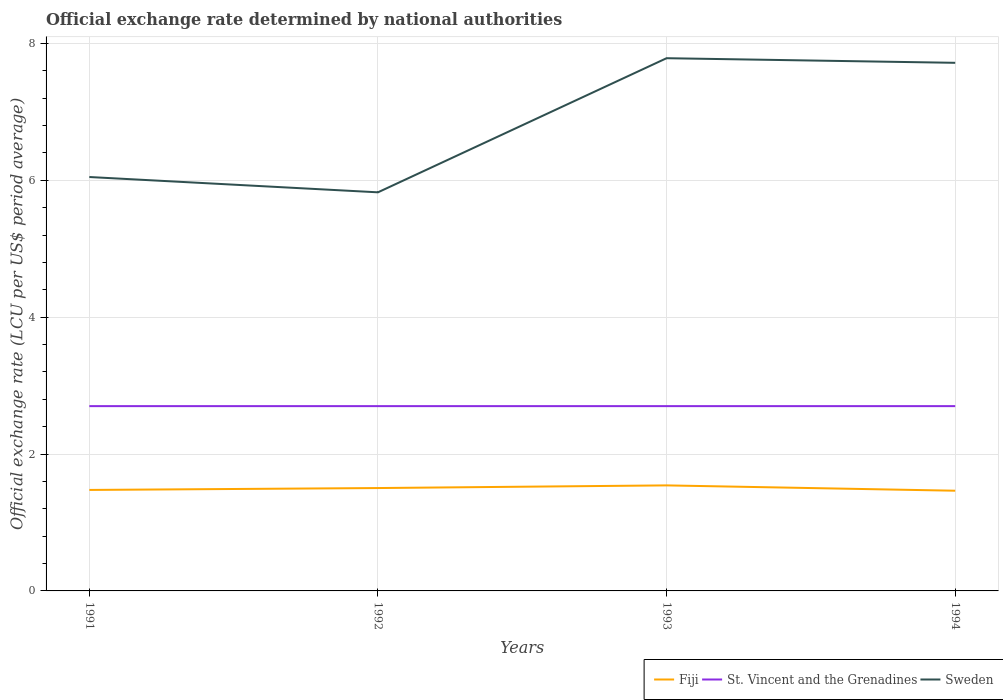Across all years, what is the maximum official exchange rate in Fiji?
Make the answer very short. 1.46. In which year was the official exchange rate in St. Vincent and the Grenadines maximum?
Keep it short and to the point. 1991. What is the difference between the highest and the second highest official exchange rate in Fiji?
Ensure brevity in your answer.  0.08. What is the difference between the highest and the lowest official exchange rate in Fiji?
Provide a succinct answer. 2. Is the official exchange rate in Sweden strictly greater than the official exchange rate in St. Vincent and the Grenadines over the years?
Give a very brief answer. No. How many lines are there?
Your answer should be very brief. 3. How many years are there in the graph?
Provide a succinct answer. 4. Does the graph contain any zero values?
Give a very brief answer. No. How many legend labels are there?
Provide a short and direct response. 3. How are the legend labels stacked?
Keep it short and to the point. Horizontal. What is the title of the graph?
Provide a succinct answer. Official exchange rate determined by national authorities. What is the label or title of the Y-axis?
Your response must be concise. Official exchange rate (LCU per US$ period average). What is the Official exchange rate (LCU per US$ period average) in Fiji in 1991?
Provide a short and direct response. 1.48. What is the Official exchange rate (LCU per US$ period average) of St. Vincent and the Grenadines in 1991?
Give a very brief answer. 2.7. What is the Official exchange rate (LCU per US$ period average) of Sweden in 1991?
Provide a succinct answer. 6.05. What is the Official exchange rate (LCU per US$ period average) in Fiji in 1992?
Keep it short and to the point. 1.5. What is the Official exchange rate (LCU per US$ period average) in St. Vincent and the Grenadines in 1992?
Your answer should be very brief. 2.7. What is the Official exchange rate (LCU per US$ period average) in Sweden in 1992?
Keep it short and to the point. 5.82. What is the Official exchange rate (LCU per US$ period average) in Fiji in 1993?
Give a very brief answer. 1.54. What is the Official exchange rate (LCU per US$ period average) of St. Vincent and the Grenadines in 1993?
Offer a very short reply. 2.7. What is the Official exchange rate (LCU per US$ period average) in Sweden in 1993?
Your response must be concise. 7.78. What is the Official exchange rate (LCU per US$ period average) in Fiji in 1994?
Provide a short and direct response. 1.46. What is the Official exchange rate (LCU per US$ period average) in St. Vincent and the Grenadines in 1994?
Ensure brevity in your answer.  2.7. What is the Official exchange rate (LCU per US$ period average) in Sweden in 1994?
Offer a very short reply. 7.72. Across all years, what is the maximum Official exchange rate (LCU per US$ period average) of Fiji?
Make the answer very short. 1.54. Across all years, what is the maximum Official exchange rate (LCU per US$ period average) of St. Vincent and the Grenadines?
Make the answer very short. 2.7. Across all years, what is the maximum Official exchange rate (LCU per US$ period average) of Sweden?
Your answer should be compact. 7.78. Across all years, what is the minimum Official exchange rate (LCU per US$ period average) of Fiji?
Provide a short and direct response. 1.46. Across all years, what is the minimum Official exchange rate (LCU per US$ period average) of St. Vincent and the Grenadines?
Your response must be concise. 2.7. Across all years, what is the minimum Official exchange rate (LCU per US$ period average) in Sweden?
Give a very brief answer. 5.82. What is the total Official exchange rate (LCU per US$ period average) of Fiji in the graph?
Provide a succinct answer. 5.98. What is the total Official exchange rate (LCU per US$ period average) in St. Vincent and the Grenadines in the graph?
Your answer should be very brief. 10.8. What is the total Official exchange rate (LCU per US$ period average) of Sweden in the graph?
Your answer should be compact. 27.37. What is the difference between the Official exchange rate (LCU per US$ period average) in Fiji in 1991 and that in 1992?
Your response must be concise. -0.03. What is the difference between the Official exchange rate (LCU per US$ period average) of St. Vincent and the Grenadines in 1991 and that in 1992?
Offer a very short reply. 0. What is the difference between the Official exchange rate (LCU per US$ period average) in Sweden in 1991 and that in 1992?
Give a very brief answer. 0.22. What is the difference between the Official exchange rate (LCU per US$ period average) of Fiji in 1991 and that in 1993?
Provide a succinct answer. -0.07. What is the difference between the Official exchange rate (LCU per US$ period average) of Sweden in 1991 and that in 1993?
Provide a short and direct response. -1.74. What is the difference between the Official exchange rate (LCU per US$ period average) in Fiji in 1991 and that in 1994?
Your answer should be compact. 0.01. What is the difference between the Official exchange rate (LCU per US$ period average) of St. Vincent and the Grenadines in 1991 and that in 1994?
Your answer should be compact. 0. What is the difference between the Official exchange rate (LCU per US$ period average) of Sweden in 1991 and that in 1994?
Your answer should be compact. -1.67. What is the difference between the Official exchange rate (LCU per US$ period average) in Fiji in 1992 and that in 1993?
Make the answer very short. -0.04. What is the difference between the Official exchange rate (LCU per US$ period average) of St. Vincent and the Grenadines in 1992 and that in 1993?
Provide a short and direct response. 0. What is the difference between the Official exchange rate (LCU per US$ period average) of Sweden in 1992 and that in 1993?
Offer a very short reply. -1.96. What is the difference between the Official exchange rate (LCU per US$ period average) of Fiji in 1992 and that in 1994?
Offer a terse response. 0.04. What is the difference between the Official exchange rate (LCU per US$ period average) of St. Vincent and the Grenadines in 1992 and that in 1994?
Keep it short and to the point. 0. What is the difference between the Official exchange rate (LCU per US$ period average) in Sweden in 1992 and that in 1994?
Keep it short and to the point. -1.89. What is the difference between the Official exchange rate (LCU per US$ period average) in Fiji in 1993 and that in 1994?
Provide a short and direct response. 0.08. What is the difference between the Official exchange rate (LCU per US$ period average) of Sweden in 1993 and that in 1994?
Your response must be concise. 0.07. What is the difference between the Official exchange rate (LCU per US$ period average) in Fiji in 1991 and the Official exchange rate (LCU per US$ period average) in St. Vincent and the Grenadines in 1992?
Your answer should be compact. -1.22. What is the difference between the Official exchange rate (LCU per US$ period average) in Fiji in 1991 and the Official exchange rate (LCU per US$ period average) in Sweden in 1992?
Your answer should be very brief. -4.35. What is the difference between the Official exchange rate (LCU per US$ period average) in St. Vincent and the Grenadines in 1991 and the Official exchange rate (LCU per US$ period average) in Sweden in 1992?
Offer a terse response. -3.12. What is the difference between the Official exchange rate (LCU per US$ period average) of Fiji in 1991 and the Official exchange rate (LCU per US$ period average) of St. Vincent and the Grenadines in 1993?
Keep it short and to the point. -1.22. What is the difference between the Official exchange rate (LCU per US$ period average) of Fiji in 1991 and the Official exchange rate (LCU per US$ period average) of Sweden in 1993?
Provide a short and direct response. -6.31. What is the difference between the Official exchange rate (LCU per US$ period average) in St. Vincent and the Grenadines in 1991 and the Official exchange rate (LCU per US$ period average) in Sweden in 1993?
Make the answer very short. -5.08. What is the difference between the Official exchange rate (LCU per US$ period average) in Fiji in 1991 and the Official exchange rate (LCU per US$ period average) in St. Vincent and the Grenadines in 1994?
Offer a terse response. -1.22. What is the difference between the Official exchange rate (LCU per US$ period average) in Fiji in 1991 and the Official exchange rate (LCU per US$ period average) in Sweden in 1994?
Give a very brief answer. -6.24. What is the difference between the Official exchange rate (LCU per US$ period average) of St. Vincent and the Grenadines in 1991 and the Official exchange rate (LCU per US$ period average) of Sweden in 1994?
Provide a short and direct response. -5.02. What is the difference between the Official exchange rate (LCU per US$ period average) in Fiji in 1992 and the Official exchange rate (LCU per US$ period average) in St. Vincent and the Grenadines in 1993?
Offer a terse response. -1.2. What is the difference between the Official exchange rate (LCU per US$ period average) of Fiji in 1992 and the Official exchange rate (LCU per US$ period average) of Sweden in 1993?
Keep it short and to the point. -6.28. What is the difference between the Official exchange rate (LCU per US$ period average) in St. Vincent and the Grenadines in 1992 and the Official exchange rate (LCU per US$ period average) in Sweden in 1993?
Your response must be concise. -5.08. What is the difference between the Official exchange rate (LCU per US$ period average) in Fiji in 1992 and the Official exchange rate (LCU per US$ period average) in St. Vincent and the Grenadines in 1994?
Give a very brief answer. -1.2. What is the difference between the Official exchange rate (LCU per US$ period average) of Fiji in 1992 and the Official exchange rate (LCU per US$ period average) of Sweden in 1994?
Make the answer very short. -6.21. What is the difference between the Official exchange rate (LCU per US$ period average) in St. Vincent and the Grenadines in 1992 and the Official exchange rate (LCU per US$ period average) in Sweden in 1994?
Keep it short and to the point. -5.02. What is the difference between the Official exchange rate (LCU per US$ period average) in Fiji in 1993 and the Official exchange rate (LCU per US$ period average) in St. Vincent and the Grenadines in 1994?
Provide a short and direct response. -1.16. What is the difference between the Official exchange rate (LCU per US$ period average) in Fiji in 1993 and the Official exchange rate (LCU per US$ period average) in Sweden in 1994?
Ensure brevity in your answer.  -6.17. What is the difference between the Official exchange rate (LCU per US$ period average) of St. Vincent and the Grenadines in 1993 and the Official exchange rate (LCU per US$ period average) of Sweden in 1994?
Your response must be concise. -5.02. What is the average Official exchange rate (LCU per US$ period average) of Fiji per year?
Provide a succinct answer. 1.5. What is the average Official exchange rate (LCU per US$ period average) in Sweden per year?
Your response must be concise. 6.84. In the year 1991, what is the difference between the Official exchange rate (LCU per US$ period average) of Fiji and Official exchange rate (LCU per US$ period average) of St. Vincent and the Grenadines?
Keep it short and to the point. -1.22. In the year 1991, what is the difference between the Official exchange rate (LCU per US$ period average) of Fiji and Official exchange rate (LCU per US$ period average) of Sweden?
Provide a succinct answer. -4.57. In the year 1991, what is the difference between the Official exchange rate (LCU per US$ period average) in St. Vincent and the Grenadines and Official exchange rate (LCU per US$ period average) in Sweden?
Your answer should be compact. -3.35. In the year 1992, what is the difference between the Official exchange rate (LCU per US$ period average) in Fiji and Official exchange rate (LCU per US$ period average) in St. Vincent and the Grenadines?
Keep it short and to the point. -1.2. In the year 1992, what is the difference between the Official exchange rate (LCU per US$ period average) of Fiji and Official exchange rate (LCU per US$ period average) of Sweden?
Offer a very short reply. -4.32. In the year 1992, what is the difference between the Official exchange rate (LCU per US$ period average) of St. Vincent and the Grenadines and Official exchange rate (LCU per US$ period average) of Sweden?
Your answer should be very brief. -3.12. In the year 1993, what is the difference between the Official exchange rate (LCU per US$ period average) of Fiji and Official exchange rate (LCU per US$ period average) of St. Vincent and the Grenadines?
Offer a terse response. -1.16. In the year 1993, what is the difference between the Official exchange rate (LCU per US$ period average) in Fiji and Official exchange rate (LCU per US$ period average) in Sweden?
Ensure brevity in your answer.  -6.24. In the year 1993, what is the difference between the Official exchange rate (LCU per US$ period average) in St. Vincent and the Grenadines and Official exchange rate (LCU per US$ period average) in Sweden?
Offer a terse response. -5.08. In the year 1994, what is the difference between the Official exchange rate (LCU per US$ period average) in Fiji and Official exchange rate (LCU per US$ period average) in St. Vincent and the Grenadines?
Offer a terse response. -1.24. In the year 1994, what is the difference between the Official exchange rate (LCU per US$ period average) of Fiji and Official exchange rate (LCU per US$ period average) of Sweden?
Keep it short and to the point. -6.25. In the year 1994, what is the difference between the Official exchange rate (LCU per US$ period average) in St. Vincent and the Grenadines and Official exchange rate (LCU per US$ period average) in Sweden?
Your answer should be compact. -5.02. What is the ratio of the Official exchange rate (LCU per US$ period average) in Fiji in 1991 to that in 1992?
Your response must be concise. 0.98. What is the ratio of the Official exchange rate (LCU per US$ period average) of St. Vincent and the Grenadines in 1991 to that in 1992?
Your response must be concise. 1. What is the ratio of the Official exchange rate (LCU per US$ period average) of Sweden in 1991 to that in 1992?
Your answer should be very brief. 1.04. What is the ratio of the Official exchange rate (LCU per US$ period average) of Fiji in 1991 to that in 1993?
Your answer should be compact. 0.96. What is the ratio of the Official exchange rate (LCU per US$ period average) of Sweden in 1991 to that in 1993?
Provide a short and direct response. 0.78. What is the ratio of the Official exchange rate (LCU per US$ period average) in Fiji in 1991 to that in 1994?
Keep it short and to the point. 1.01. What is the ratio of the Official exchange rate (LCU per US$ period average) of Sweden in 1991 to that in 1994?
Offer a very short reply. 0.78. What is the ratio of the Official exchange rate (LCU per US$ period average) in Fiji in 1992 to that in 1993?
Your answer should be compact. 0.97. What is the ratio of the Official exchange rate (LCU per US$ period average) of St. Vincent and the Grenadines in 1992 to that in 1993?
Give a very brief answer. 1. What is the ratio of the Official exchange rate (LCU per US$ period average) in Sweden in 1992 to that in 1993?
Offer a very short reply. 0.75. What is the ratio of the Official exchange rate (LCU per US$ period average) of Fiji in 1992 to that in 1994?
Provide a succinct answer. 1.03. What is the ratio of the Official exchange rate (LCU per US$ period average) in Sweden in 1992 to that in 1994?
Your response must be concise. 0.75. What is the ratio of the Official exchange rate (LCU per US$ period average) in Fiji in 1993 to that in 1994?
Your answer should be very brief. 1.05. What is the ratio of the Official exchange rate (LCU per US$ period average) in Sweden in 1993 to that in 1994?
Ensure brevity in your answer.  1.01. What is the difference between the highest and the second highest Official exchange rate (LCU per US$ period average) of Fiji?
Give a very brief answer. 0.04. What is the difference between the highest and the second highest Official exchange rate (LCU per US$ period average) in St. Vincent and the Grenadines?
Provide a succinct answer. 0. What is the difference between the highest and the second highest Official exchange rate (LCU per US$ period average) of Sweden?
Ensure brevity in your answer.  0.07. What is the difference between the highest and the lowest Official exchange rate (LCU per US$ period average) of Fiji?
Your response must be concise. 0.08. What is the difference between the highest and the lowest Official exchange rate (LCU per US$ period average) of St. Vincent and the Grenadines?
Your response must be concise. 0. What is the difference between the highest and the lowest Official exchange rate (LCU per US$ period average) in Sweden?
Keep it short and to the point. 1.96. 